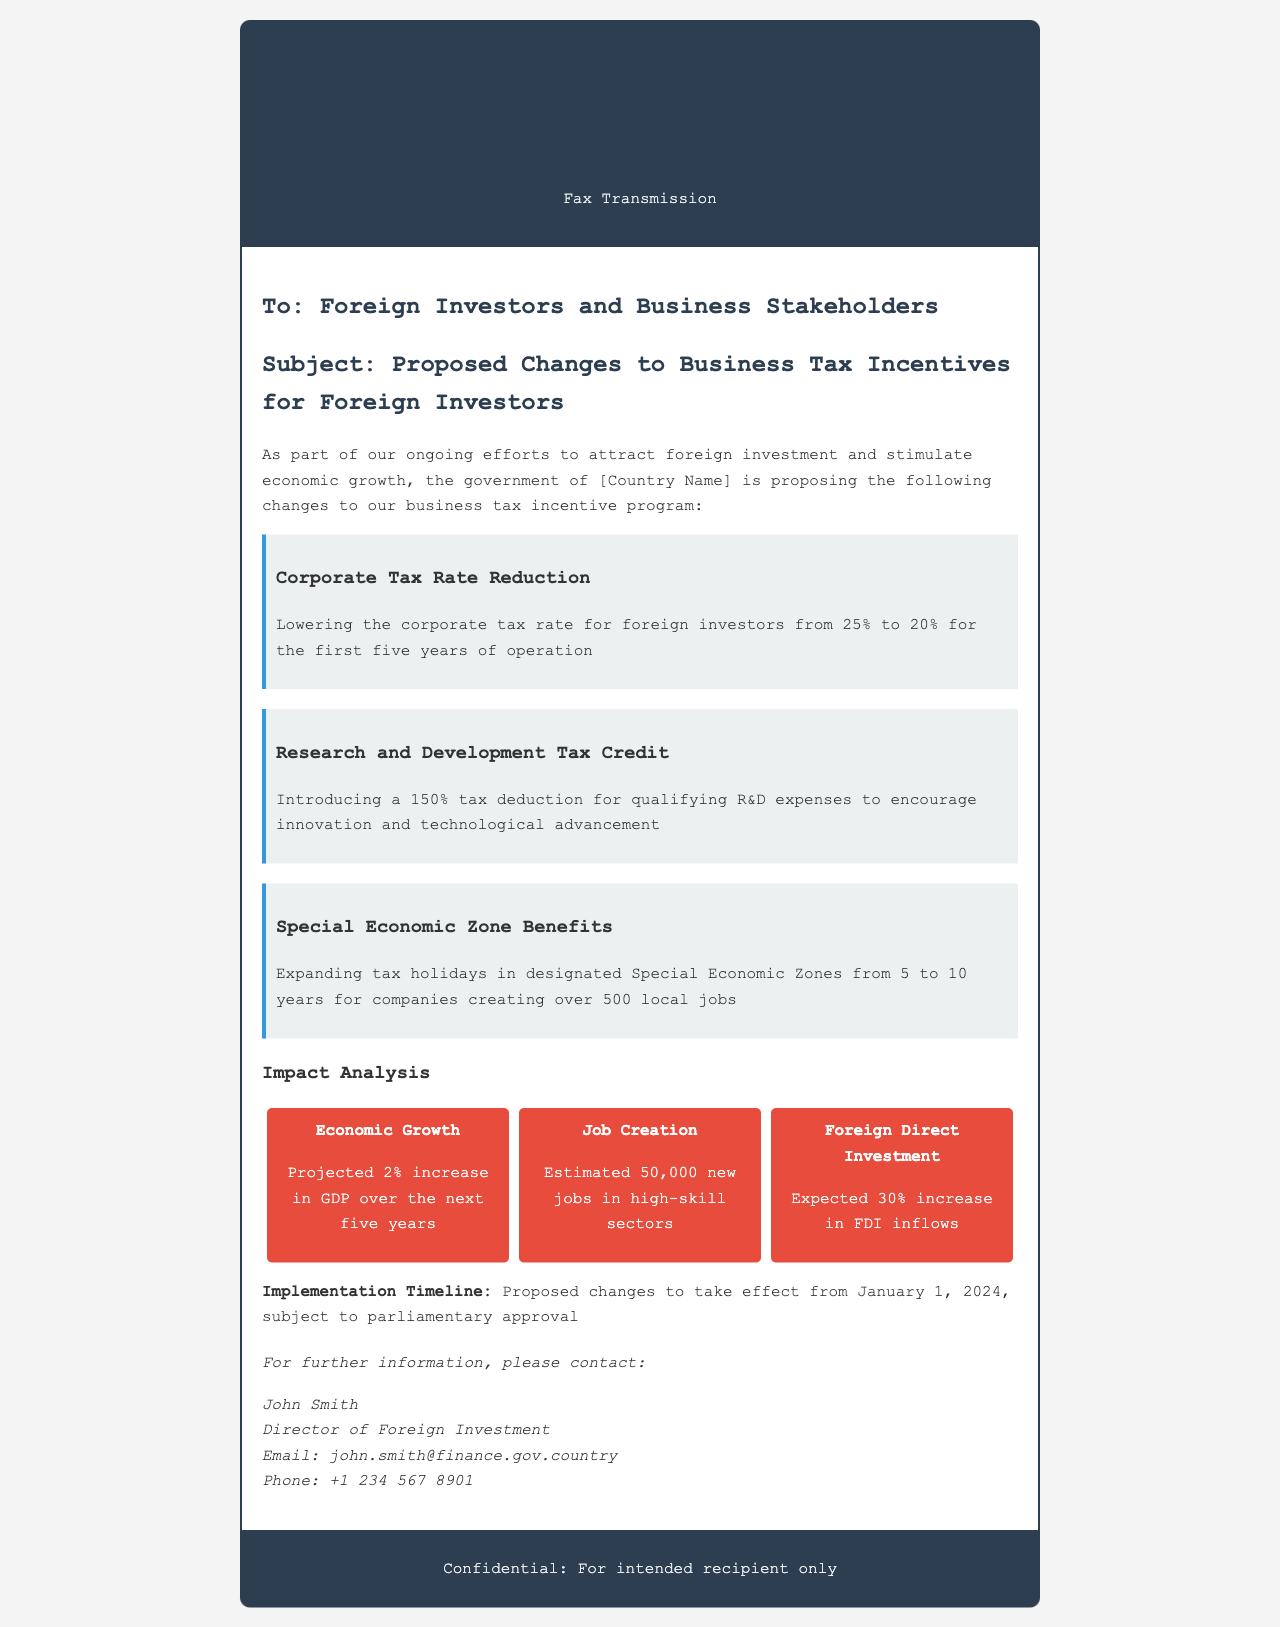what is the corporate tax rate reduction percentage? The document states the corporate tax rate is proposed to be lowered from 25% to 20%.
Answer: 20% how many new jobs are estimated to be created? The document mentions an estimated 50,000 new jobs in high-skill sectors.
Answer: 50,000 what is the implementation date for the proposed changes? The document indicates that proposed changes will take effect from January 1, 2024, subject to approval.
Answer: January 1, 2024 what percentage is the research and development tax deduction? The proposed tax deduction for qualifying R&D expenses is 150%.
Answer: 150% how long will the tax holidays last in Special Economic Zones? The proposed changes extend tax holidays in designated Special Economic Zones from 5 to 10 years.
Answer: 10 years what is the projected increase in GDP due to the proposed changes? The document states there is a projected 2% increase in GDP over the next five years.
Answer: 2% who is the contact person for further information? The document lists John Smith as the contact person for further information.
Answer: John Smith what is the estimated increase percentage in foreign direct investment inflows? The document expects a 30% increase in foreign direct investment inflows.
Answer: 30% 